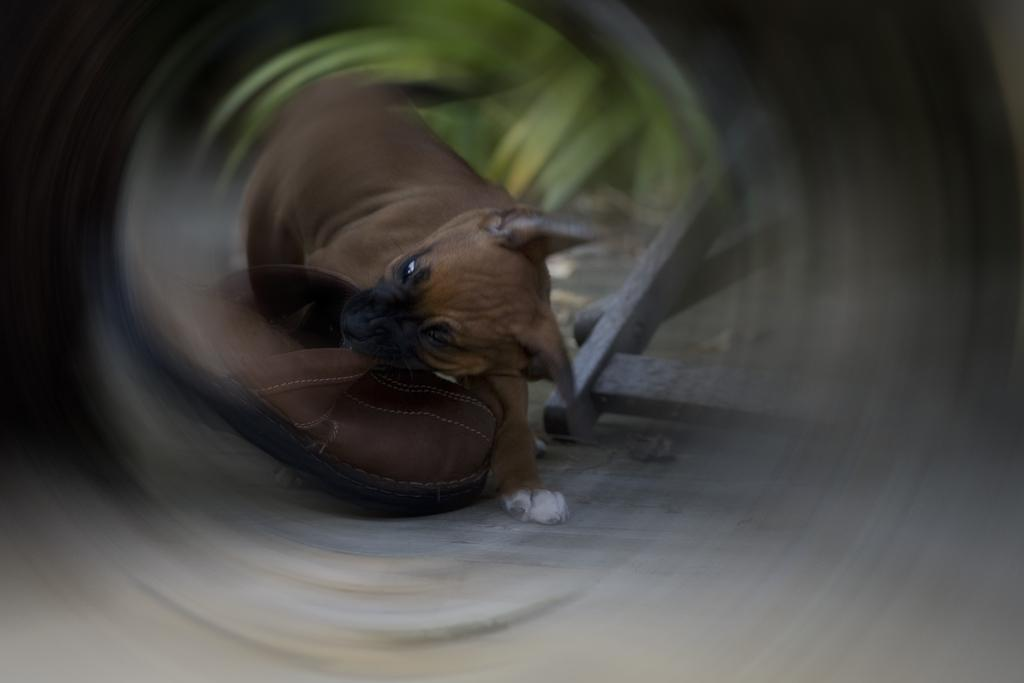What type of animal is in the image? There is a dog in the image. What other object can be seen in the image? There is a shoe in the image. What can be seen in the background of the image? There is a stand in the background of the image. What type of veil is draped over the dog in the image? There is no veil present in the image; it only features a dog, a shoe, and a stand. What type of animal is holding the mitten in the image? There is no mitten or animal holding a mitten present in the image. 